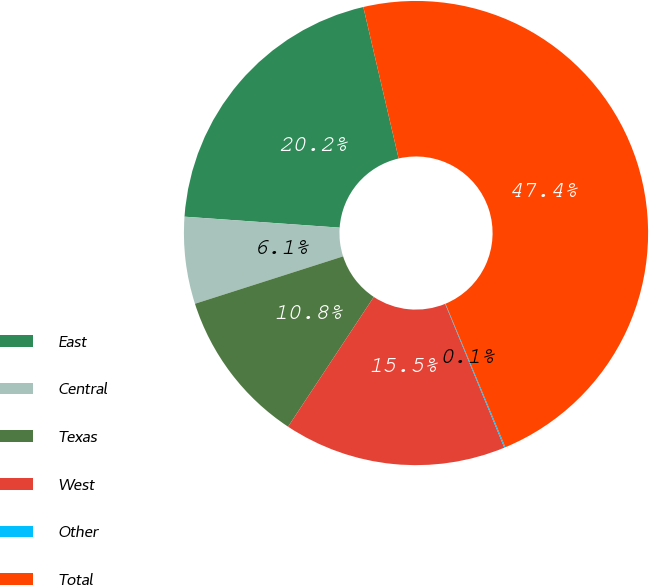Convert chart to OTSL. <chart><loc_0><loc_0><loc_500><loc_500><pie_chart><fcel>East<fcel>Central<fcel>Texas<fcel>West<fcel>Other<fcel>Total<nl><fcel>20.23%<fcel>6.05%<fcel>10.78%<fcel>15.5%<fcel>0.08%<fcel>47.35%<nl></chart> 